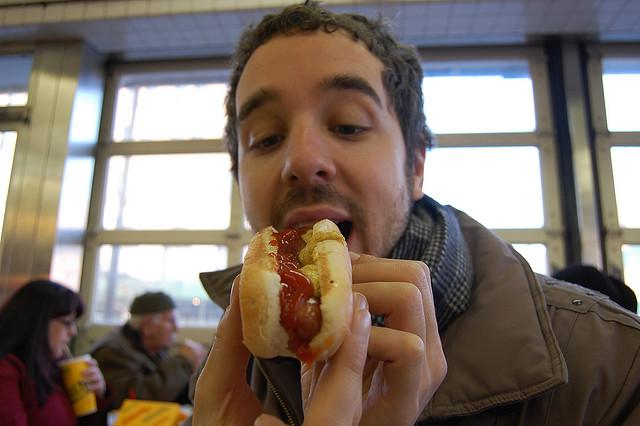What style of food is being served?

Choices:
A) indian
B) mexican
C) italian
D) american american 